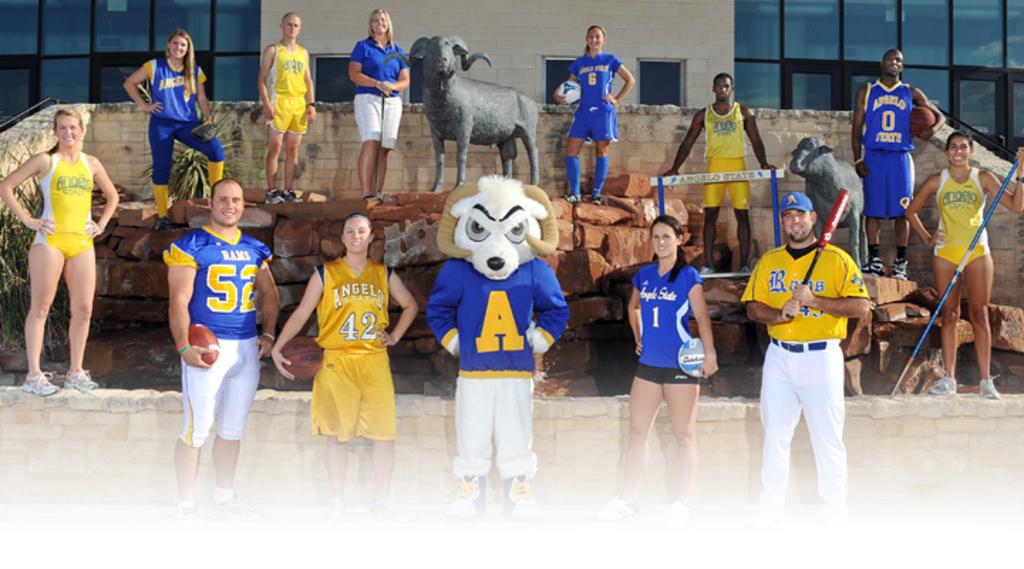What is the lady in front in yellows jersey number?
Keep it short and to the point. 42. 